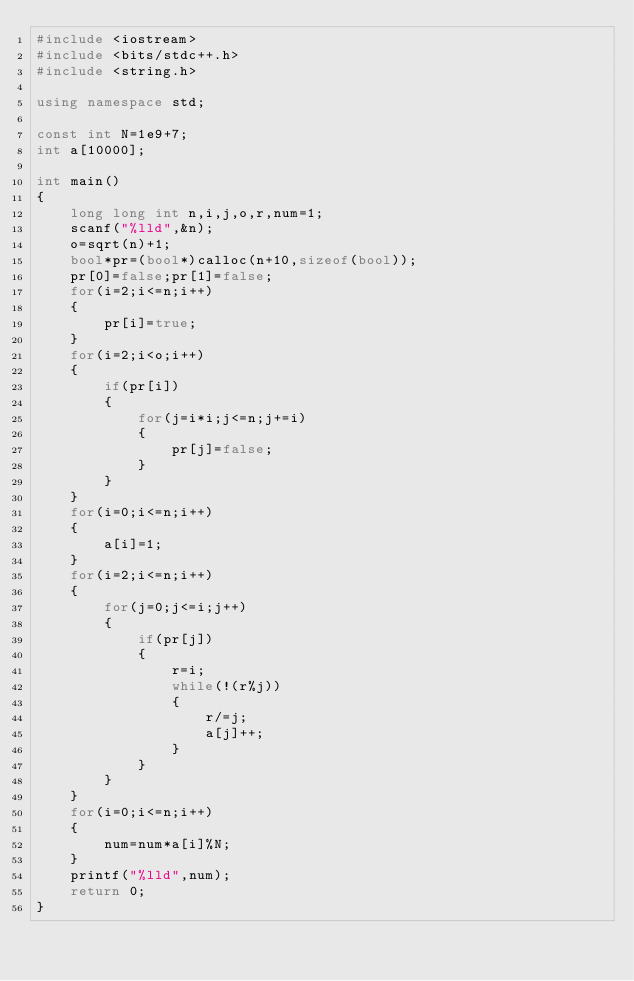Convert code to text. <code><loc_0><loc_0><loc_500><loc_500><_C++_>#include <iostream>
#include <bits/stdc++.h>
#include <string.h>

using namespace std;

const int N=1e9+7;
int a[10000];

int main()
{
    long long int n,i,j,o,r,num=1;
    scanf("%lld",&n);
    o=sqrt(n)+1;
    bool*pr=(bool*)calloc(n+10,sizeof(bool));
    pr[0]=false;pr[1]=false;
    for(i=2;i<=n;i++)
    {
        pr[i]=true;
    }
    for(i=2;i<o;i++)
    {
        if(pr[i])
        {
            for(j=i*i;j<=n;j+=i)
            {
                pr[j]=false;
            }
        }
    }
    for(i=0;i<=n;i++)
    {
        a[i]=1;
    }
    for(i=2;i<=n;i++)
    {
        for(j=0;j<=i;j++)
        {
            if(pr[j])
            {
                r=i;
                while(!(r%j))
                {
                    r/=j;
                    a[j]++;
                }
            }
        }
    }
    for(i=0;i<=n;i++)
    {
        num=num*a[i]%N;
    }
    printf("%lld",num);
    return 0;
}</code> 